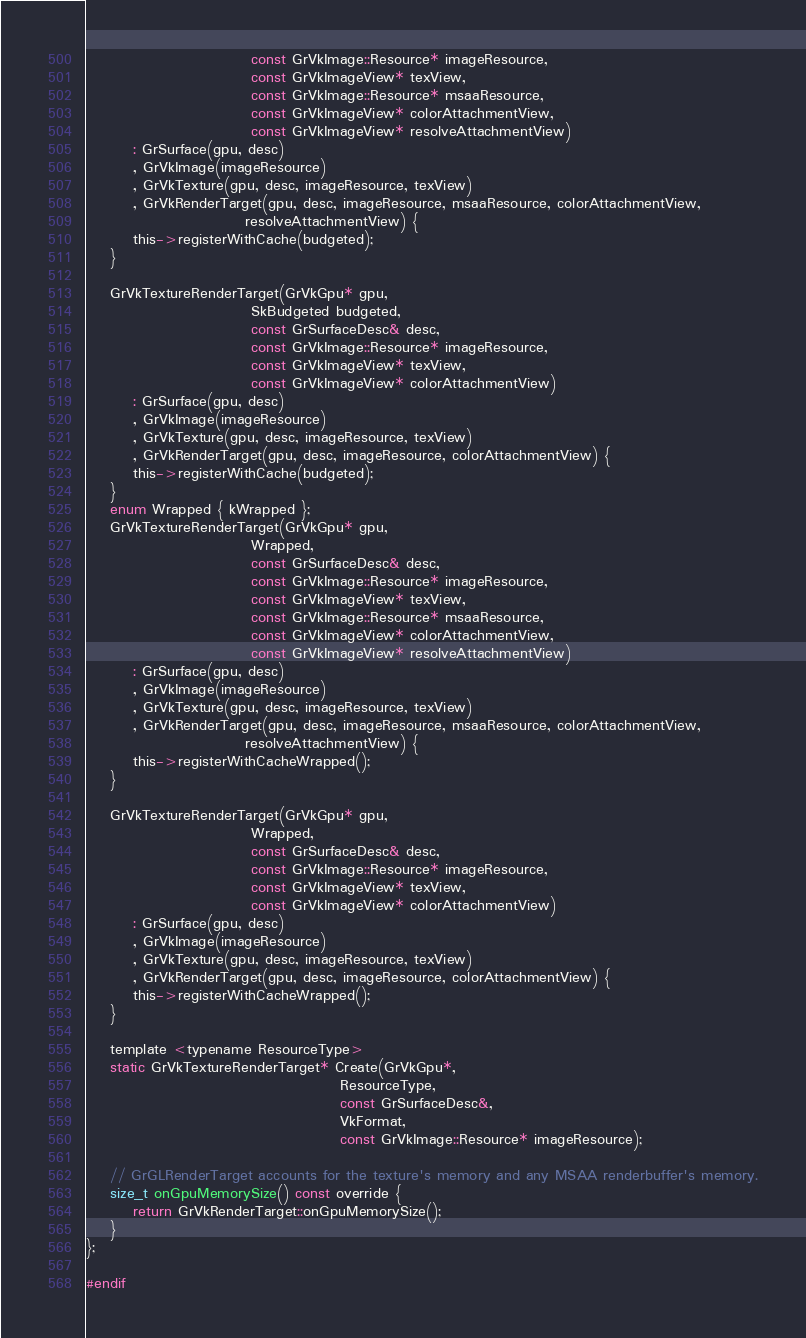<code> <loc_0><loc_0><loc_500><loc_500><_C_>                            const GrVkImage::Resource* imageResource,
                            const GrVkImageView* texView,
                            const GrVkImage::Resource* msaaResource,
                            const GrVkImageView* colorAttachmentView,
                            const GrVkImageView* resolveAttachmentView)
        : GrSurface(gpu, desc)
        , GrVkImage(imageResource)
        , GrVkTexture(gpu, desc, imageResource, texView)
        , GrVkRenderTarget(gpu, desc, imageResource, msaaResource, colorAttachmentView,
                           resolveAttachmentView) {
        this->registerWithCache(budgeted);
    }

    GrVkTextureRenderTarget(GrVkGpu* gpu,
                            SkBudgeted budgeted,
                            const GrSurfaceDesc& desc,
                            const GrVkImage::Resource* imageResource,
                            const GrVkImageView* texView,
                            const GrVkImageView* colorAttachmentView)
        : GrSurface(gpu, desc)
        , GrVkImage(imageResource)
        , GrVkTexture(gpu, desc, imageResource, texView)
        , GrVkRenderTarget(gpu, desc, imageResource, colorAttachmentView) {
        this->registerWithCache(budgeted);
    }
    enum Wrapped { kWrapped };
    GrVkTextureRenderTarget(GrVkGpu* gpu,
                            Wrapped,
                            const GrSurfaceDesc& desc,
                            const GrVkImage::Resource* imageResource,
                            const GrVkImageView* texView,
                            const GrVkImage::Resource* msaaResource,
                            const GrVkImageView* colorAttachmentView,
                            const GrVkImageView* resolveAttachmentView)
        : GrSurface(gpu, desc)
        , GrVkImage(imageResource)
        , GrVkTexture(gpu, desc, imageResource, texView)
        , GrVkRenderTarget(gpu, desc, imageResource, msaaResource, colorAttachmentView,
                           resolveAttachmentView) {
        this->registerWithCacheWrapped();
    }

    GrVkTextureRenderTarget(GrVkGpu* gpu,
                            Wrapped,
                            const GrSurfaceDesc& desc,
                            const GrVkImage::Resource* imageResource,
                            const GrVkImageView* texView,
                            const GrVkImageView* colorAttachmentView)
        : GrSurface(gpu, desc)
        , GrVkImage(imageResource)
        , GrVkTexture(gpu, desc, imageResource, texView)
        , GrVkRenderTarget(gpu, desc, imageResource, colorAttachmentView) {
        this->registerWithCacheWrapped();
    }

    template <typename ResourceType>
    static GrVkTextureRenderTarget* Create(GrVkGpu*,
                                           ResourceType,
                                           const GrSurfaceDesc&,
                                           VkFormat,
                                           const GrVkImage::Resource* imageResource);

    // GrGLRenderTarget accounts for the texture's memory and any MSAA renderbuffer's memory.
    size_t onGpuMemorySize() const override {
        return GrVkRenderTarget::onGpuMemorySize();
    }
};

#endif
</code> 